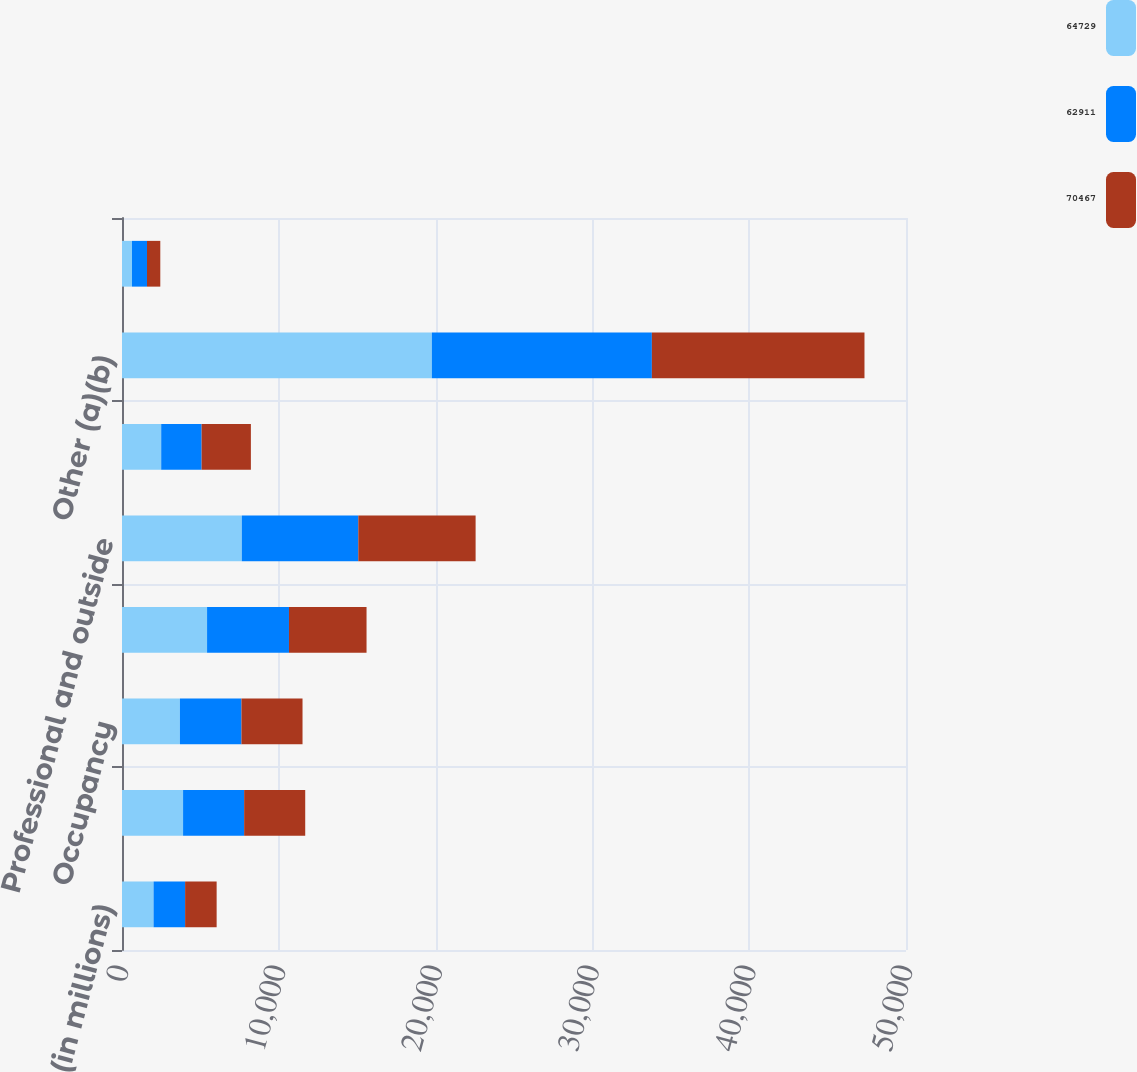Convert chart. <chart><loc_0><loc_0><loc_500><loc_500><stacked_bar_chart><ecel><fcel>(in millions)<fcel>Compensation expense<fcel>Occupancy<fcel>Technology communications and<fcel>Professional and outside<fcel>Marketing<fcel>Other (a)(b)<fcel>Amortization of intangibles<nl><fcel>64729<fcel>2013<fcel>3895<fcel>3693<fcel>5425<fcel>7641<fcel>2500<fcel>19761<fcel>637<nl><fcel>62911<fcel>2012<fcel>3895<fcel>3925<fcel>5224<fcel>7429<fcel>2577<fcel>14032<fcel>957<nl><fcel>70467<fcel>2011<fcel>3895<fcel>3895<fcel>4947<fcel>7482<fcel>3143<fcel>13559<fcel>848<nl></chart> 